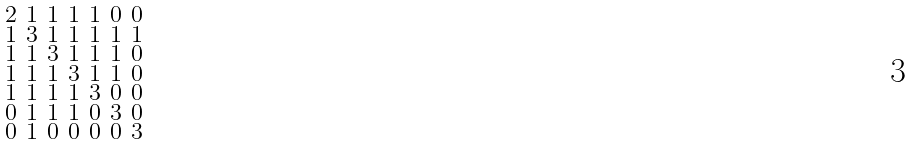Convert formula to latex. <formula><loc_0><loc_0><loc_500><loc_500>\begin{smallmatrix} 2 & 1 & 1 & 1 & 1 & 0 & 0 \\ 1 & 3 & 1 & 1 & 1 & 1 & 1 \\ 1 & 1 & 3 & 1 & 1 & 1 & 0 \\ 1 & 1 & 1 & 3 & 1 & 1 & 0 \\ 1 & 1 & 1 & 1 & 3 & 0 & 0 \\ 0 & 1 & 1 & 1 & 0 & 3 & 0 \\ 0 & 1 & 0 & 0 & 0 & 0 & 3 \end{smallmatrix}</formula> 